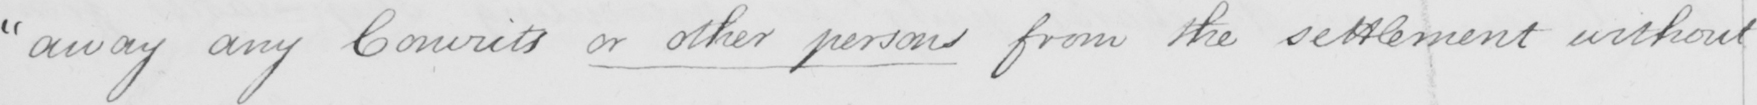Please transcribe the handwritten text in this image. " away any Convicts or other persons from the settlement without 